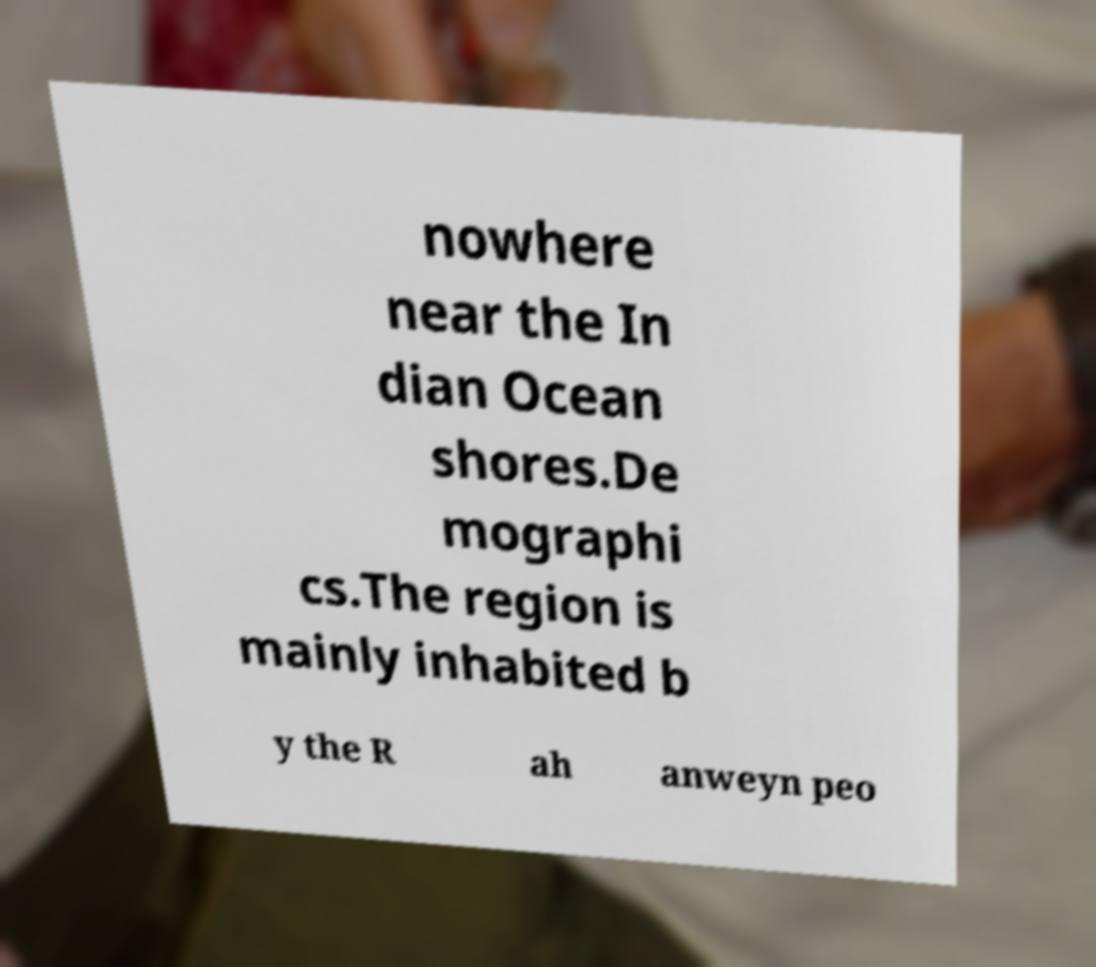Could you assist in decoding the text presented in this image and type it out clearly? nowhere near the In dian Ocean shores.De mographi cs.The region is mainly inhabited b y the R ah anweyn peo 